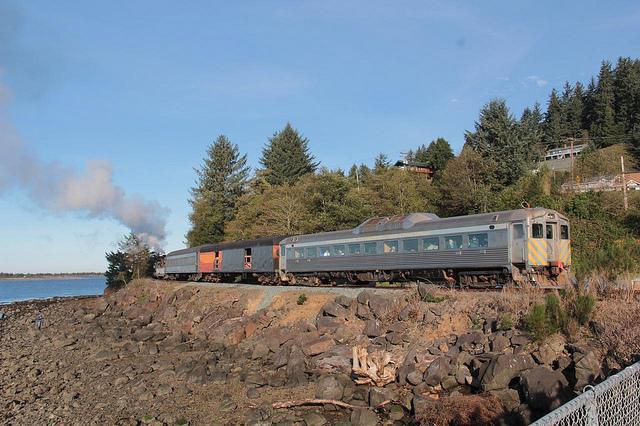How many keyboards are shown?
Give a very brief answer. 0. 